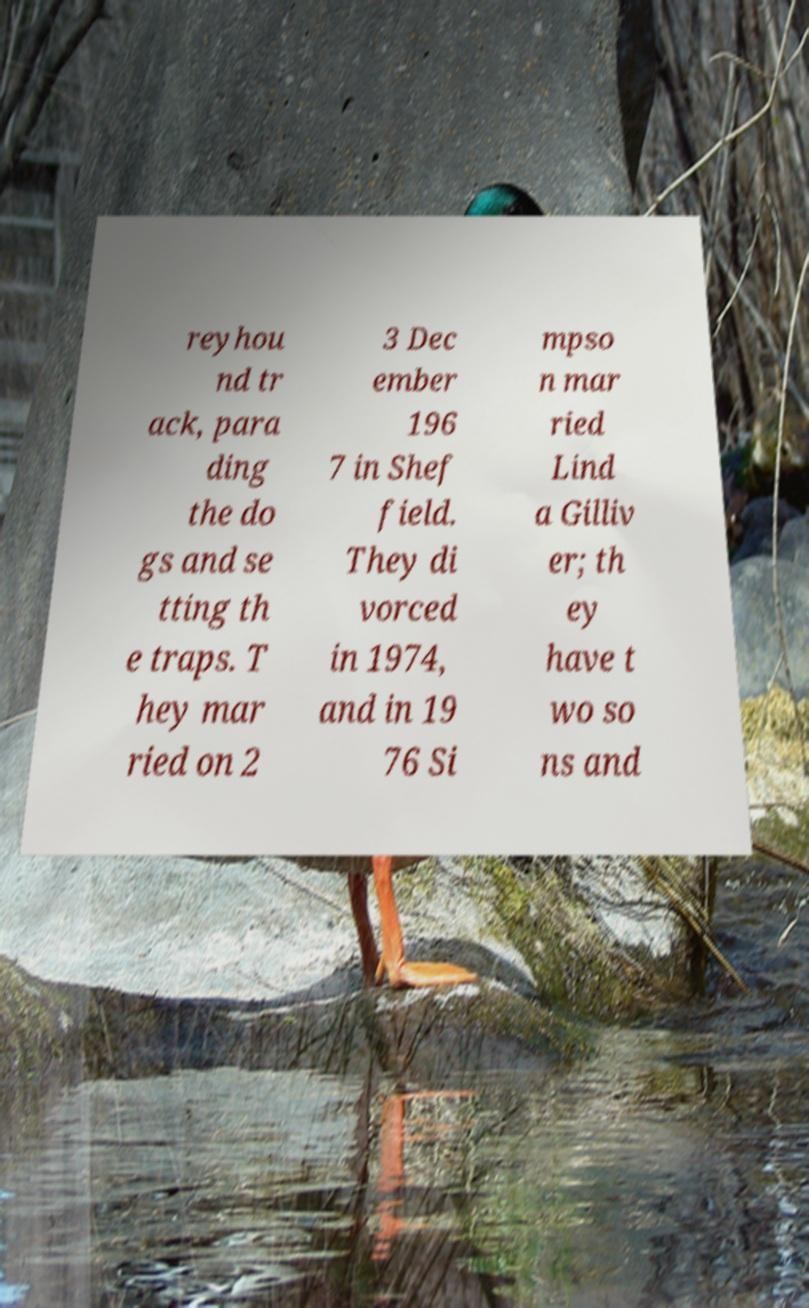Please identify and transcribe the text found in this image. reyhou nd tr ack, para ding the do gs and se tting th e traps. T hey mar ried on 2 3 Dec ember 196 7 in Shef field. They di vorced in 1974, and in 19 76 Si mpso n mar ried Lind a Gilliv er; th ey have t wo so ns and 